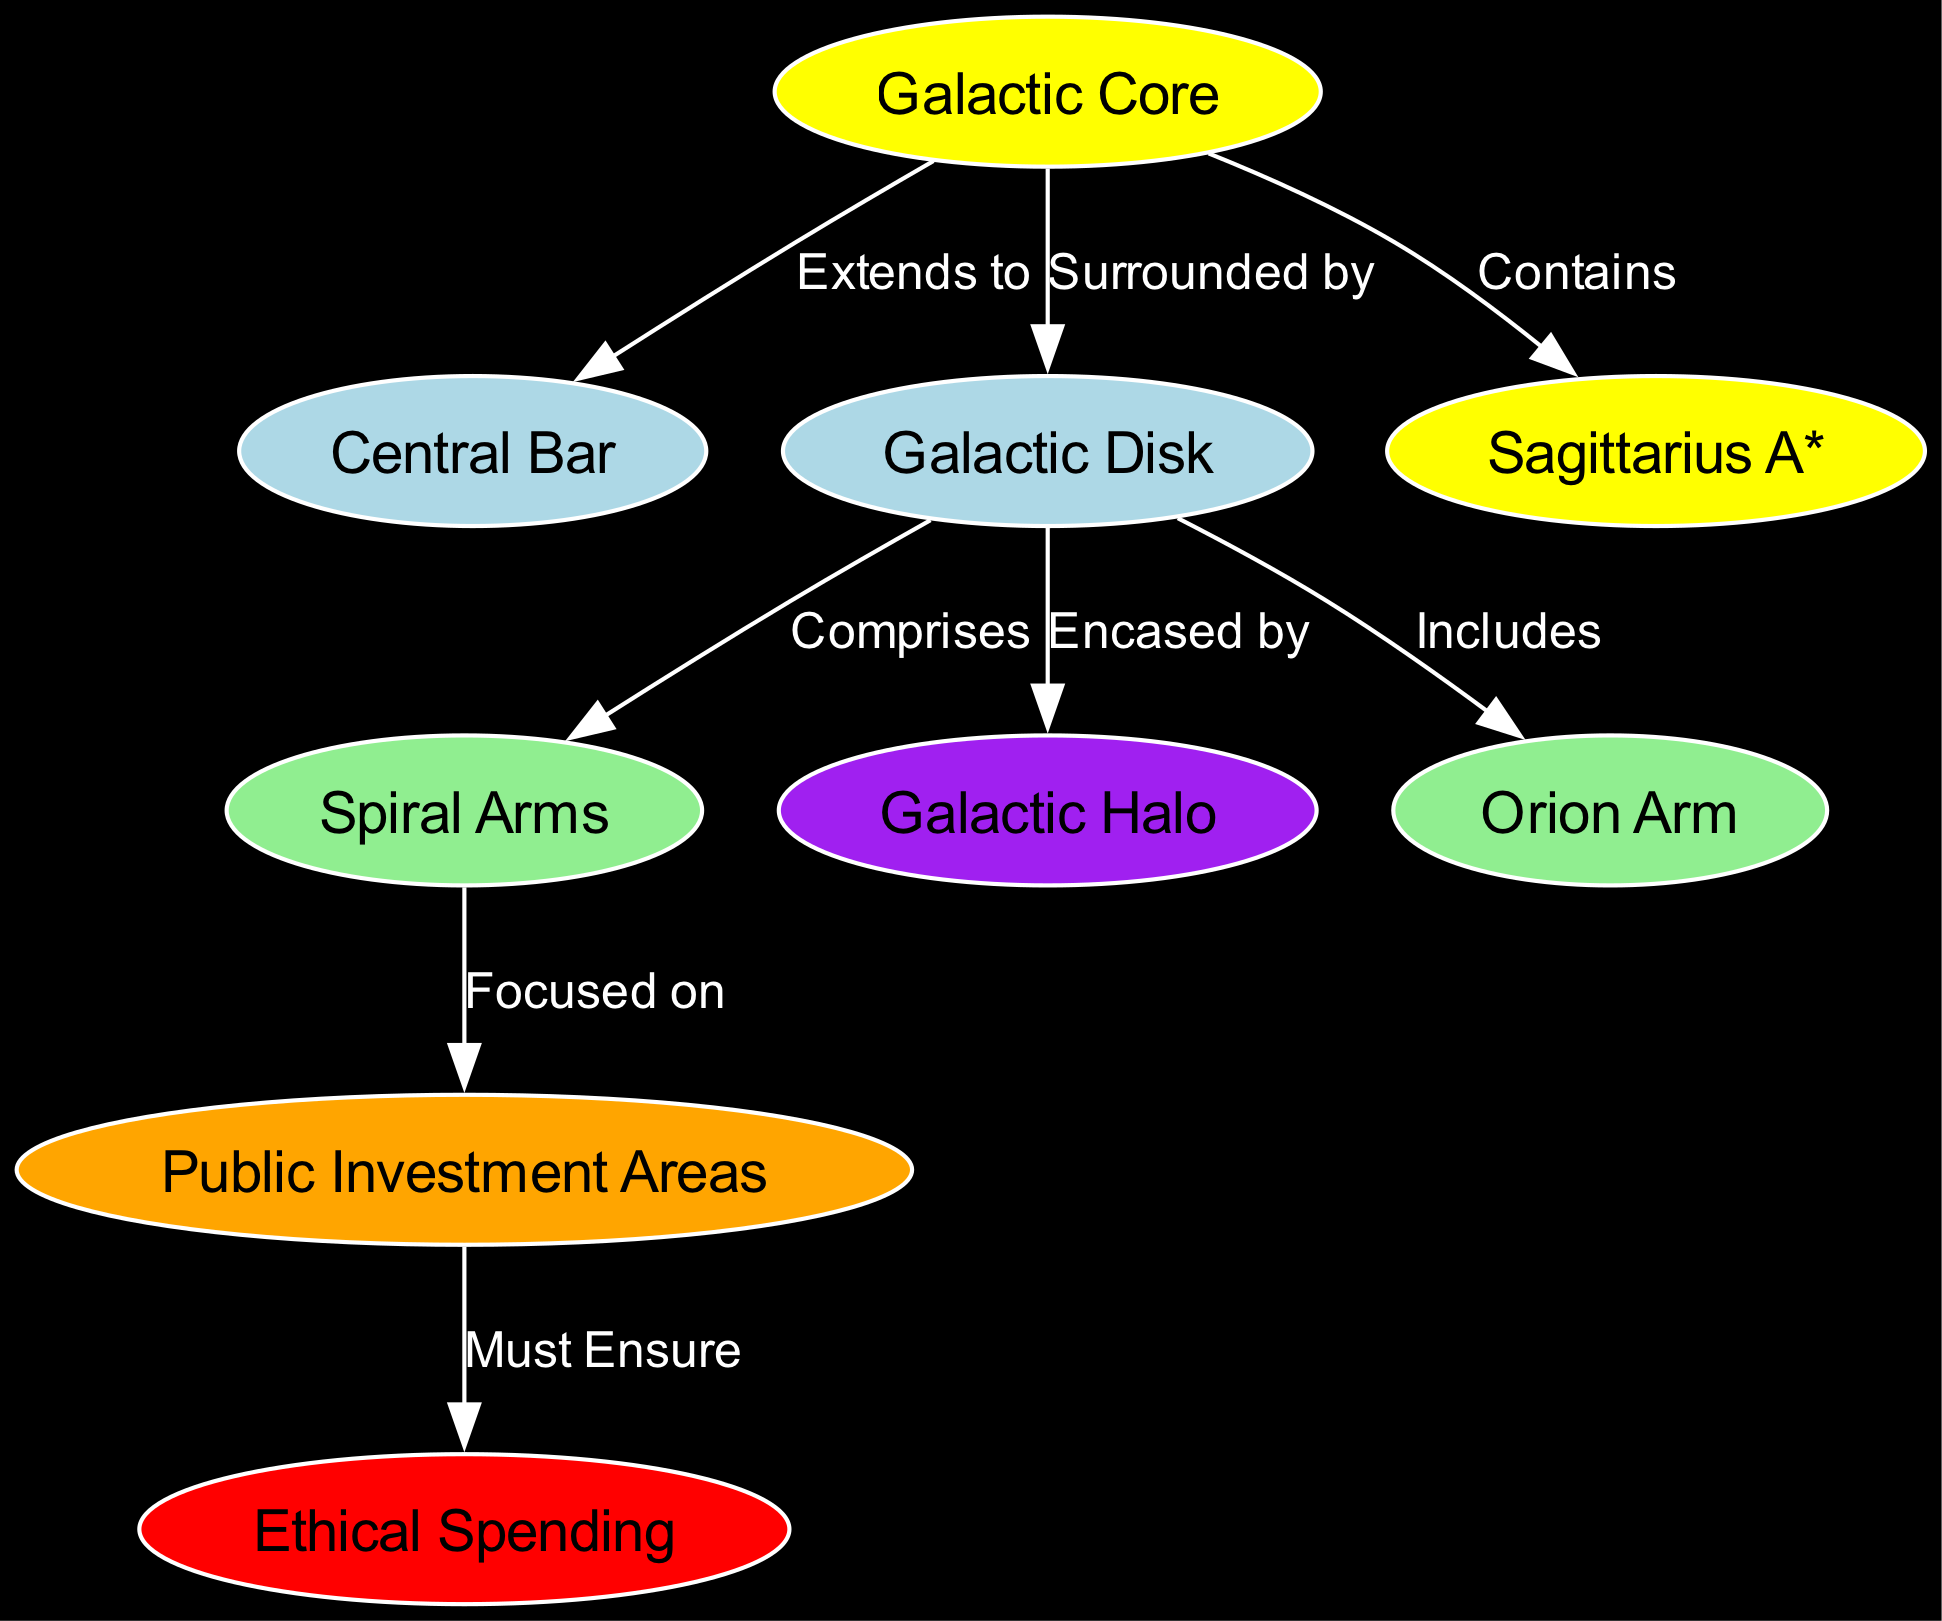What is at the center of the Milky Way galaxy? The diagram shows a direct connection from the Core node to the Sagittarius A* node, indicating that Sagittarius A* is located at the center of the galaxy.
Answer: Sagittarius A* How many primary regions are identified in the diagram? The nodes consist of Core, Bar, Disk, Spiral Arms, Halo, Sagittarius A*, Orion Arm, Public Investment Areas, and Ethical Spending. Counting these nodes gives a total of 9 regions.
Answer: 9 Which region is the focus of public investments in space exploration? The diagram indicates that the Spiral Arms are directly connected to the Public Investment Areas, denoting that the focus of investments lies in this region specifically.
Answer: Spiral Arms What ethical consideration is highlighted regarding public investments? The edge from Public Investment Areas to the EthicsNode emphasizes the importance of ensuring ethical spending, showing a commitment to transparent use of public resources.
Answer: Ethical Spending Which part of the galaxy is where our Solar System is located? The diagram connects the Orion Arm directly to the Disk, which includes the designation that this arm is where our Solar System resides.
Answer: Orion Arm What type of structure extends from the galactic core? The diagram indicates that there is a relationship where the Central Bar extends from the Core, meaning the Core is directly connected to this elongated structure.
Answer: Central Bar Which region is encased by the Galactic Disk? The diagram shows a connection where the Disk encases the Halo, providing a clear relationship indicating that the Halo is the region encased by the Disk.
Answer: Halo What is one of the distinctive roles of the Spiral Arms? The diagram demonstrates that the Spiral Arms are regions of higher star density and are sites of active star formation, highlighting their role within the galaxy.
Answer: Active star formation Where in the galaxy do older stars and globular clusters reside? The connection between the Disk and the Halo reveals that the Halo is specifically where older stars and globular clusters are found.
Answer: Galactic Halo 